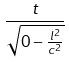<formula> <loc_0><loc_0><loc_500><loc_500>\frac { t } { \sqrt { 0 - \frac { l ^ { 2 } } { c ^ { 2 } } } }</formula> 